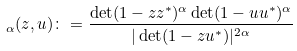Convert formula to latex. <formula><loc_0><loc_0><loc_500><loc_500>\L _ { \alpha } ( z , u ) \colon = \frac { \det ( 1 - z z ^ { * } ) ^ { \alpha } \det ( 1 - u u ^ { * } ) ^ { \alpha } } { | \det ( 1 - z u ^ { * } ) | ^ { 2 \alpha } }</formula> 